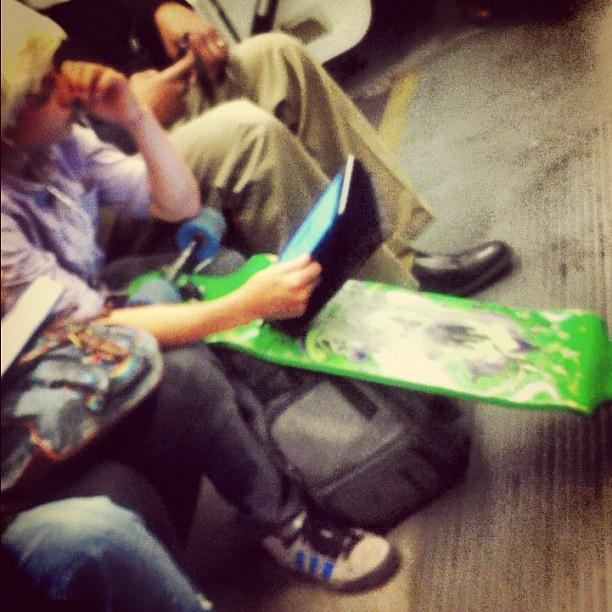What device is the boy holding? Please explain your reasoning. tablet. The device is handheld, but it is bigger than  a phone. 